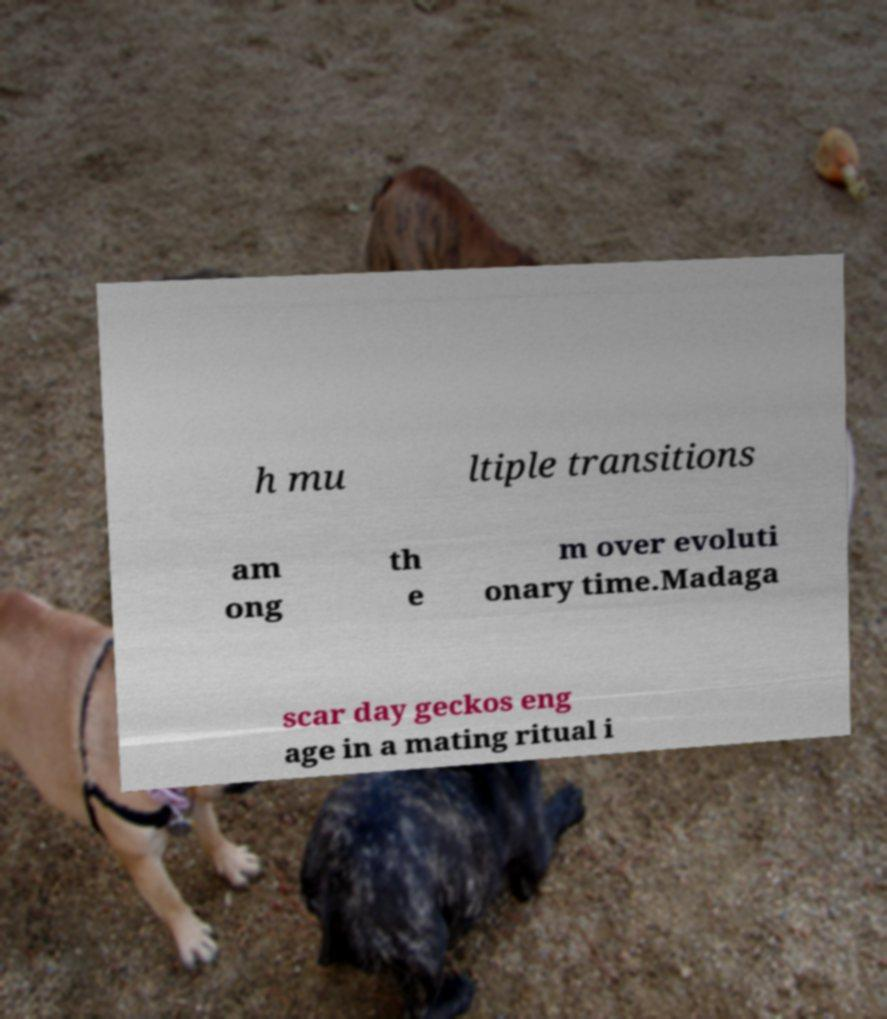Please identify and transcribe the text found in this image. h mu ltiple transitions am ong th e m over evoluti onary time.Madaga scar day geckos eng age in a mating ritual i 